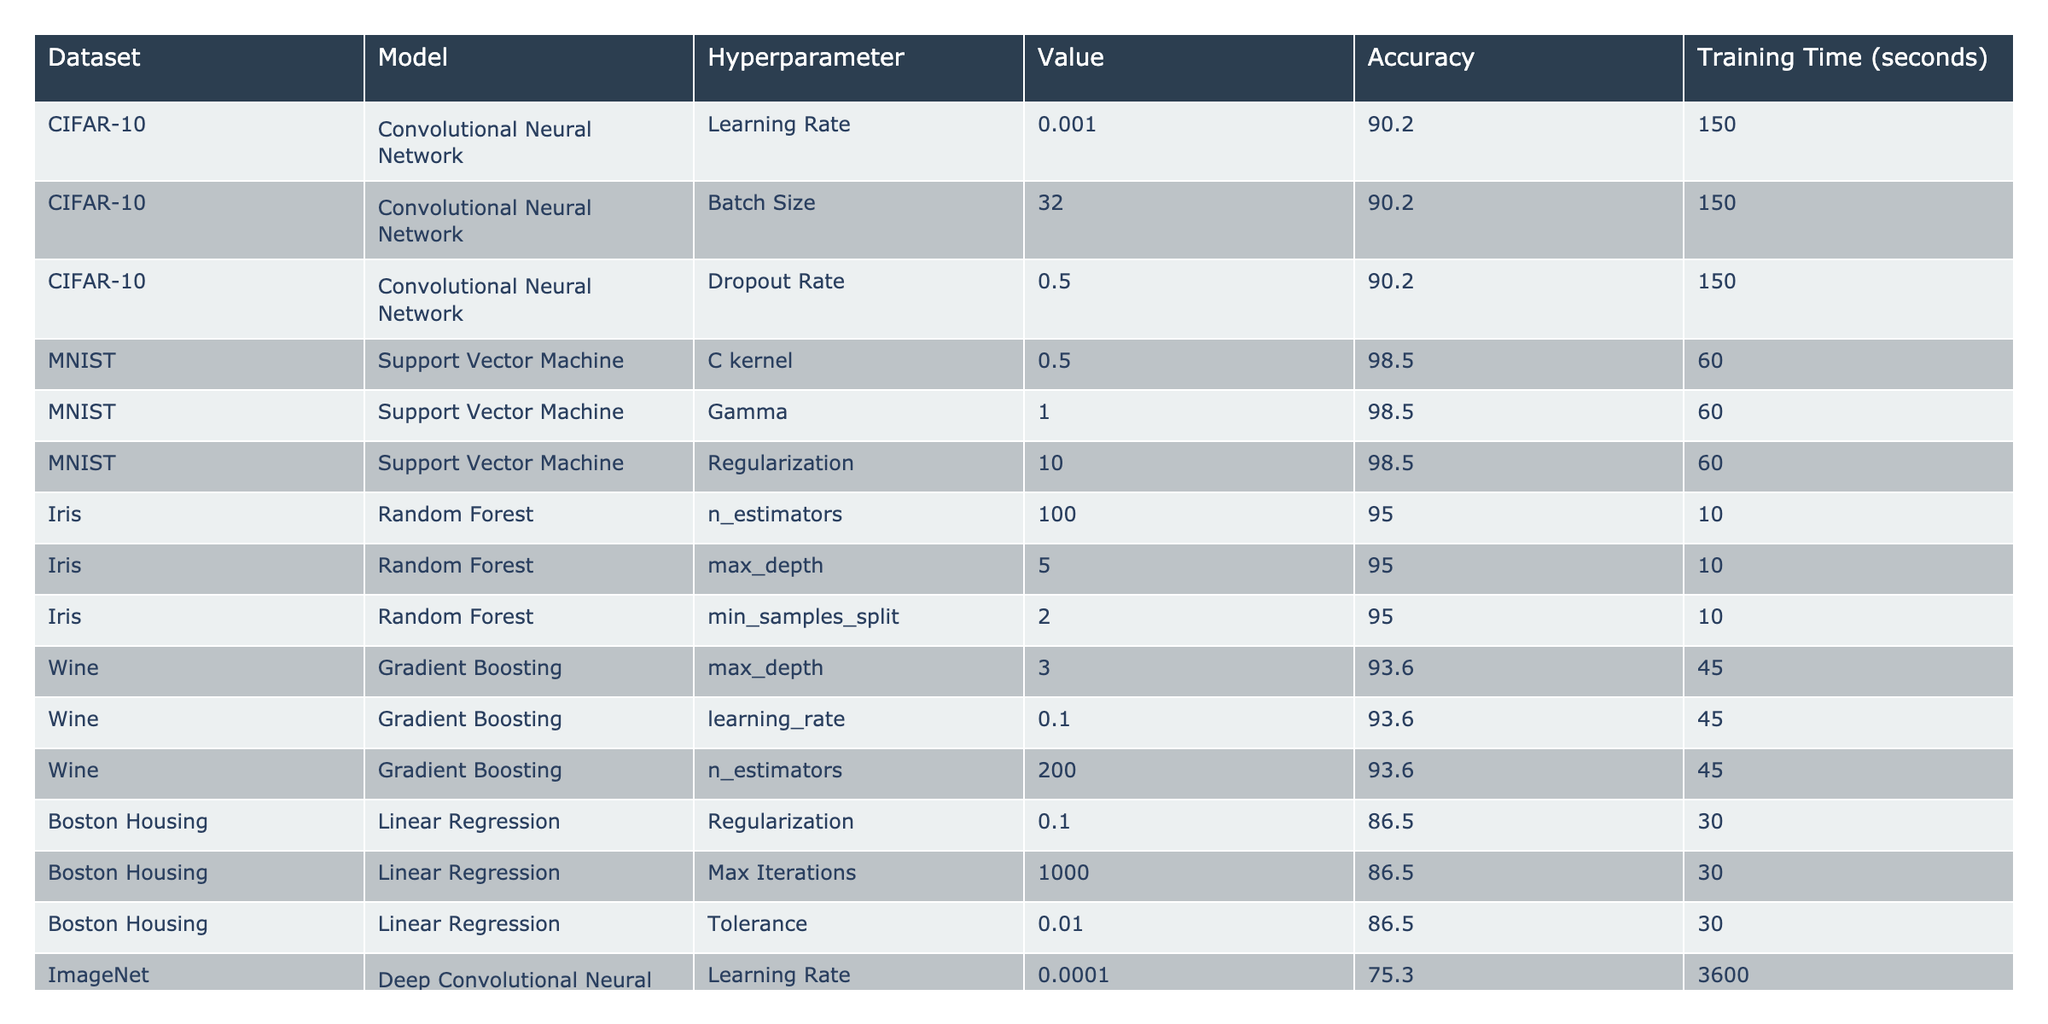What is the accuracy of the Support Vector Machine on the MNIST dataset? The table indicates that the Support Vector Machine achieves an accuracy of 98.5 on the MNIST dataset.
Answer: 98.5 What model achieved the highest accuracy and what is that accuracy? The model with the highest accuracy is the Support Vector Machine on the MNIST dataset, achieving an accuracy of 98.5.
Answer: Support Vector Machine, 98.5 Which dataset had the least training time, and what was that time? The Iris dataset had the least training time at 10 seconds, as shown in the table.
Answer: 10 seconds What is the maximum depth for the Random Forest model on the Iris dataset? The maximum depth for the Random Forest model on the Iris dataset is 5, according to the table.
Answer: 5 Is the accuracy of the Convolutional Neural Network on the CIFAR-10 dataset higher than that of the Deep Convolutional Neural Network on the ImageNet dataset? Yes, the Convolutional Neural Network on the CIFAR-10 dataset has an accuracy of 90.2, which is higher than the Deep Convolutional Neural Network's accuracy of 75.3 on ImageNet.
Answer: Yes How much longer does the Deep Convolutional Neural Network take to train compared to the Support Vector Machine? The Deep Convolutional Neural Network takes 3600 seconds to train, while the Support Vector Machine takes 60 seconds. The difference is 3600 - 60 = 3540 seconds.
Answer: 3540 seconds What is the average accuracy across all datasets listed for the Gradient Boosting model? The Gradient Boosting model achieved an accuracy of 93.6 on the Wine dataset. Since it is the only dataset listed for this model, the average accuracy is 93.6.
Answer: 93.6 Which model has the most hyperparameter settings listed in the table? The Support Vector Machine has three hyperparameter settings listed (C kernel, Gamma, Regularization), which is more than any other model.
Answer: Support Vector Machine What is the combined accuracy of the Linear Regression model on the Boston Housing dataset compared to the Random Forest on the Iris dataset? The combined accuracy is 86.5 (Linear Regression) + 95.0 (Random Forest) = 181.5.
Answer: 181.5 Are the hyperparameters for the Deep Convolutional Neural Network consistent in terms of their values, or do they vary? The hyperparameters for the Deep Convolutional Neural Network vary; they include different values for Learning Rate, Dropout Rate, and Batch Size.
Answer: They vary 